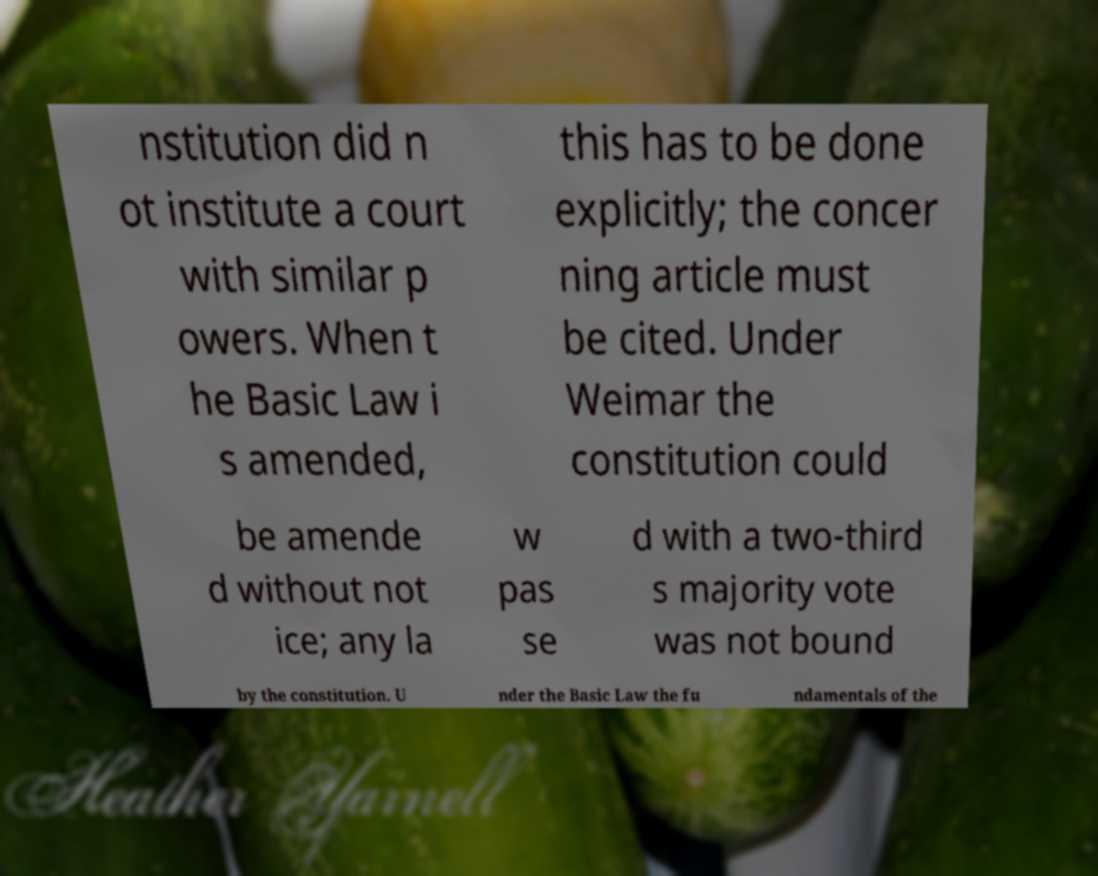There's text embedded in this image that I need extracted. Can you transcribe it verbatim? nstitution did n ot institute a court with similar p owers. When t he Basic Law i s amended, this has to be done explicitly; the concer ning article must be cited. Under Weimar the constitution could be amende d without not ice; any la w pas se d with a two-third s majority vote was not bound by the constitution. U nder the Basic Law the fu ndamentals of the 